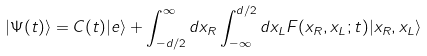<formula> <loc_0><loc_0><loc_500><loc_500>| \Psi ( t ) \rangle = C ( t ) | e \rangle + \int _ { - d / 2 } ^ { \infty } d x _ { R } \int _ { - \infty } ^ { d / 2 } d x _ { L } F ( x _ { R } , x _ { L } ; t ) | x _ { R } , x _ { L } \rangle</formula> 